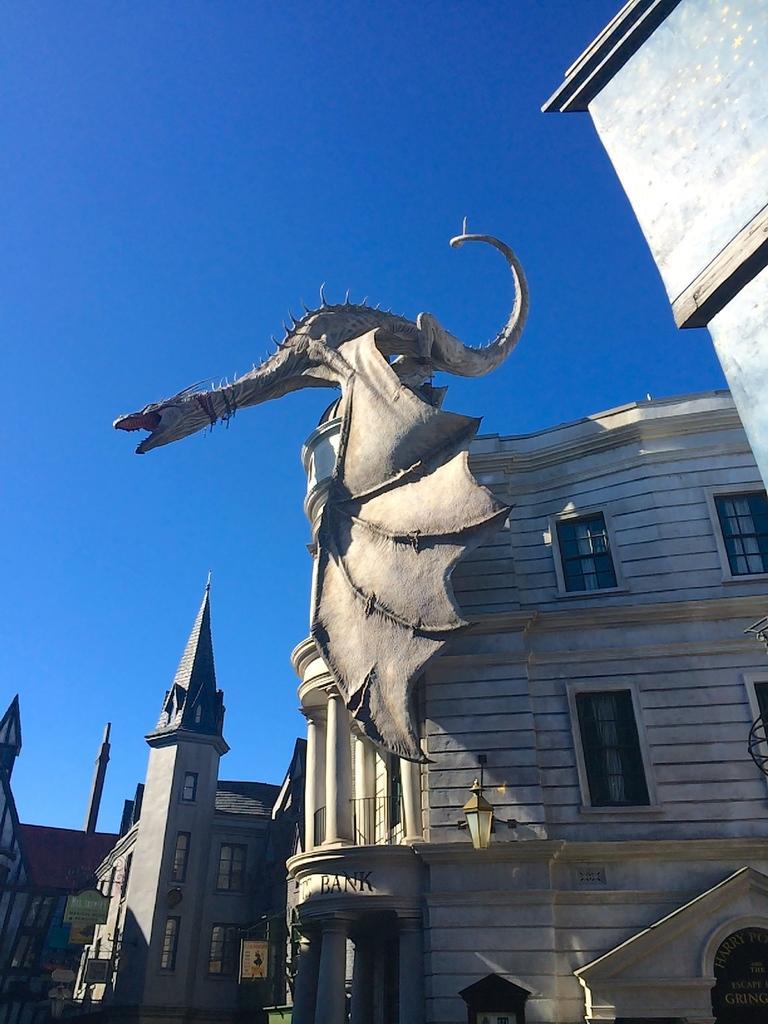In one or two sentences, can you explain what this image depicts? In this picture we can see buildings with windows, boards, statue and in the background we can see the sky. 